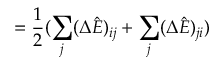Convert formula to latex. <formula><loc_0><loc_0><loc_500><loc_500>= \frac { 1 } { 2 } ( \sum _ { j } ( \Delta \hat { E } ) _ { i j } + \sum _ { j } ( \Delta \hat { E } ) _ { j i } )</formula> 